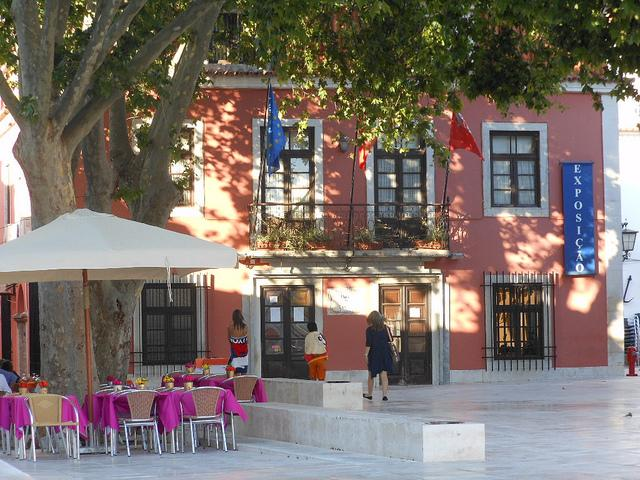What event is being held here? wedding 